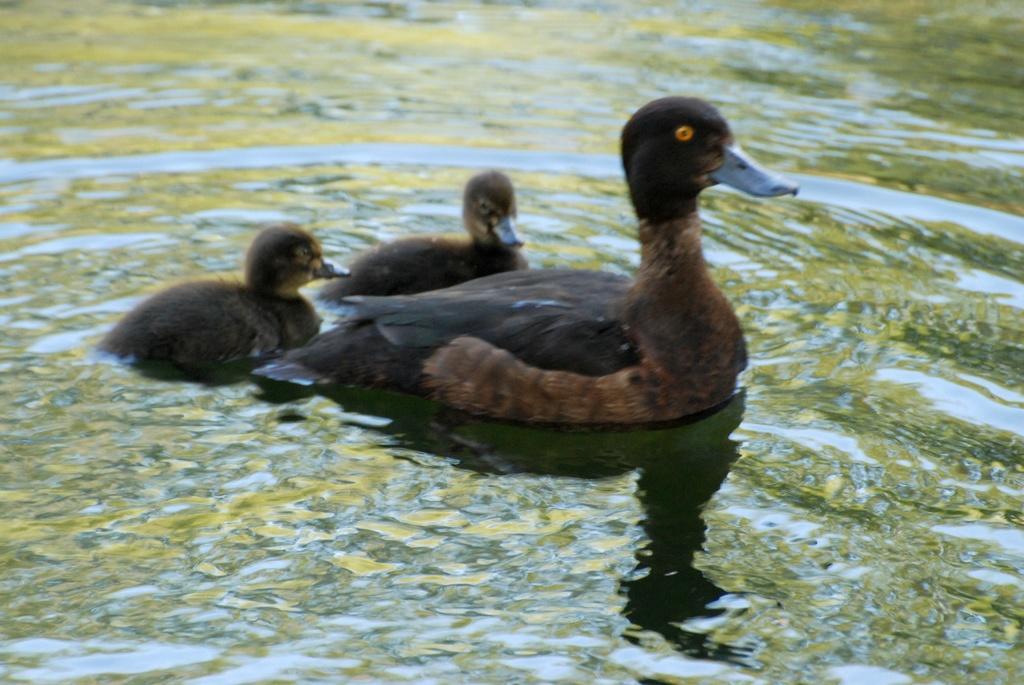In one or two sentences, can you explain what this image depicts? In this image there are a few ducks on the water. 